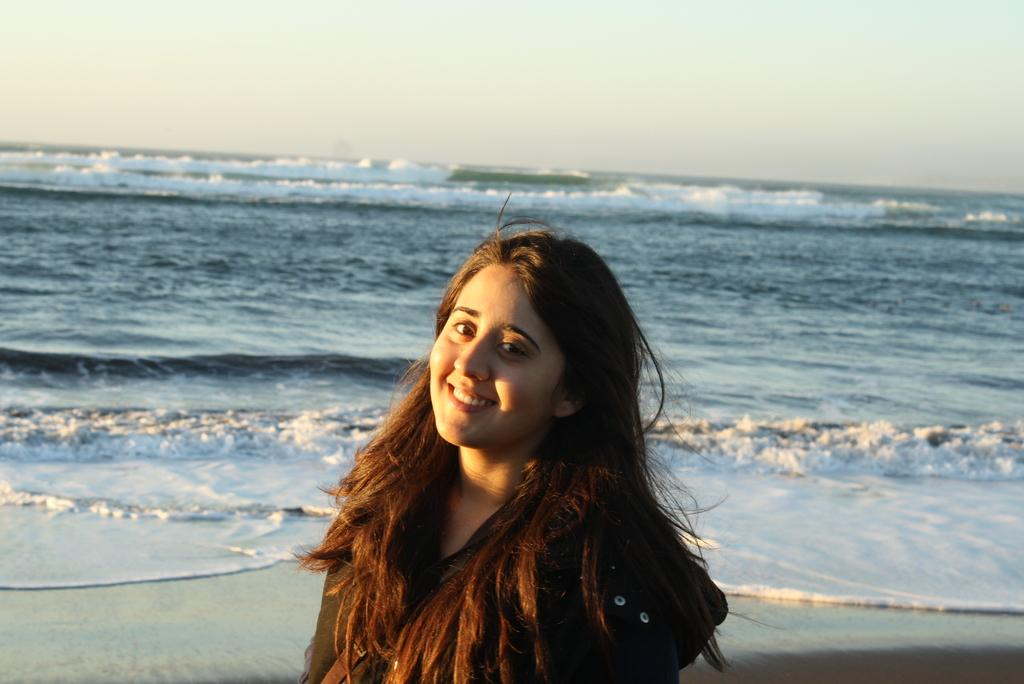Who is present in the image? There is a woman in the image. What natural feature can be seen behind the woman? There is an ocean visible behind the woman. What else is visible in the image besides the woman and the ocean? The sky is visible in the image. What type of humor can be seen in the image? There is no humor present in the image; it is a photograph of a woman standing near an ocean. 